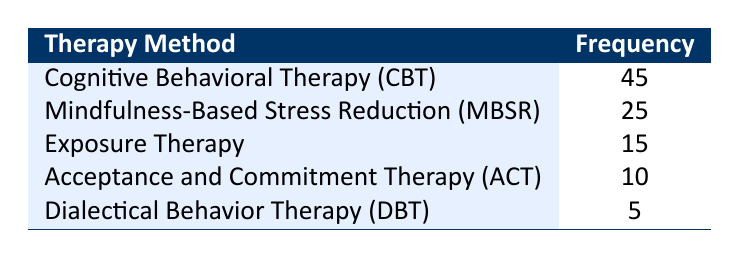What is the most utilized therapy method for anxiety and emotional disorders? The table shows the therapy methods along with their frequencies. The method with the highest frequency is Cognitive Behavioral Therapy (CBT) with a frequency of 45.
Answer: Cognitive Behavioral Therapy (CBT) How many therapy methods have a frequency of 20 or more? The methods with frequencies of 20 or more are Cognitive Behavioral Therapy (CBT) with 45 and Mindfulness-Based Stress Reduction (MBSR) with 25. That makes a total of 2 therapy methods.
Answer: 2 What is the total frequency of all therapy methods listed? To find the total frequency, sum the values: 45 (CBT) + 25 (MBSR) + 15 (Exposure Therapy) + 10 (ACT) + 5 (DBT) = 100.
Answer: 100 Is Acceptance and Commitment Therapy (ACT) one of the top three therapy methods used? Acceptance and Commitment Therapy (ACT) has a frequency of 10, which places it fourth behind CBT, MBSR, and Exposure Therapy (which have frequencies of 45, 25, and 15, respectively). Therefore, it is not one of the top three.
Answer: No What is the percentage of the frequency for Dialectical Behavior Therapy (DBT) compared to the total frequency? The frequency for Dialectical Behavior Therapy (DBT) is 5. To find its percentage of the total frequency (100), use the formula (5 / 100) * 100% = 5%.
Answer: 5% How does the frequency of Exposure Therapy compare to that of Acceptance and Commitment Therapy (ACT)? Exposure Therapy has a frequency of 15, whereas ACT has a frequency of 10. Therefore, Exposure Therapy is utilized more frequently than ACT by 5.
Answer: Exposure Therapy is utilized more than ACT by 5 What is the difference in frequency between the most and least utilized therapy methods? The most utilized method is Cognitive Behavioral Therapy (CBT) with a frequency of 45, and the least utilized is Dialectical Behavior Therapy (DBT) with a frequency of 5. The difference is 45 - 5 = 40.
Answer: 40 Which therapy method has a frequency lower than 15? The therapy methods with frequencies lower than 15 are Acceptance and Commitment Therapy (ACT) with 10 and Dialectical Behavior Therapy (DBT) with 5.
Answer: Acceptance and Commitment Therapy (ACT) and Dialectical Behavior Therapy (DBT) 